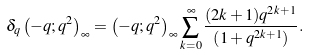<formula> <loc_0><loc_0><loc_500><loc_500>\delta _ { q } \left ( - q ; q ^ { 2 } \right ) _ { \infty } = \left ( - q ; q ^ { 2 } \right ) _ { \infty } \sum _ { k = 0 } ^ { \infty } \frac { ( 2 k + 1 ) q ^ { 2 k + 1 } } { \left ( 1 + q ^ { 2 k + 1 } \right ) } .</formula> 